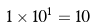Convert formula to latex. <formula><loc_0><loc_0><loc_500><loc_500>1 \times 1 0 ^ { 1 } = 1 0</formula> 